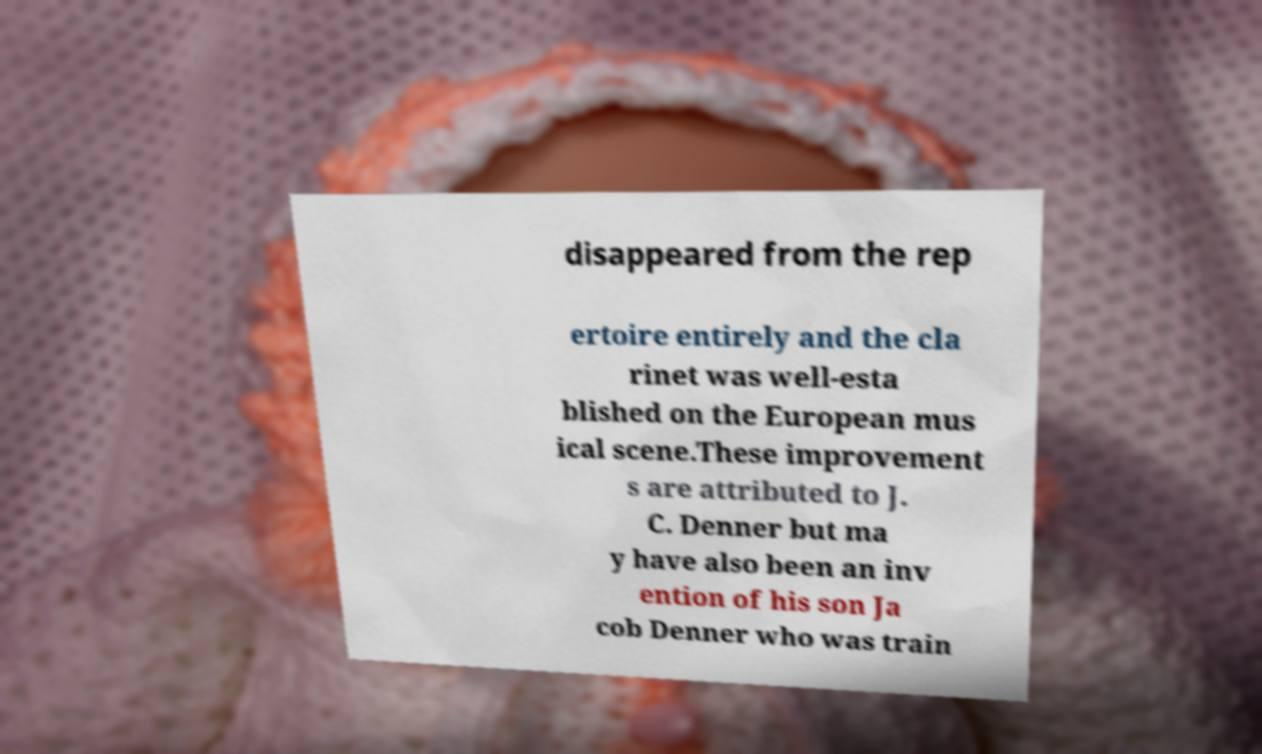What messages or text are displayed in this image? I need them in a readable, typed format. disappeared from the rep ertoire entirely and the cla rinet was well-esta blished on the European mus ical scene.These improvement s are attributed to J. C. Denner but ma y have also been an inv ention of his son Ja cob Denner who was train 